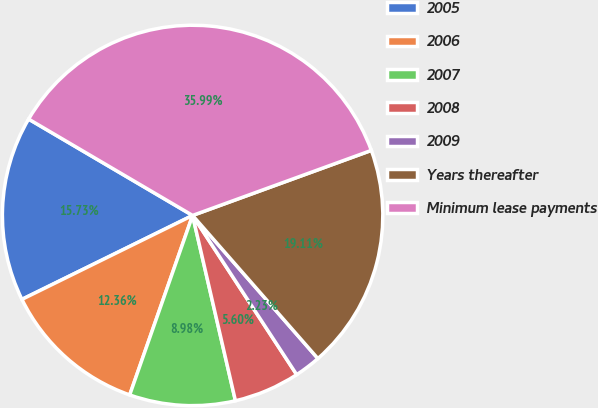<chart> <loc_0><loc_0><loc_500><loc_500><pie_chart><fcel>2005<fcel>2006<fcel>2007<fcel>2008<fcel>2009<fcel>Years thereafter<fcel>Minimum lease payments<nl><fcel>15.73%<fcel>12.36%<fcel>8.98%<fcel>5.6%<fcel>2.23%<fcel>19.11%<fcel>35.99%<nl></chart> 